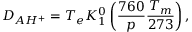Convert formula to latex. <formula><loc_0><loc_0><loc_500><loc_500>D _ { A H ^ { + } } = T _ { e } K _ { 1 } ^ { 0 } \left ( \frac { 7 6 0 } { p } \frac { T _ { m } } { 2 7 3 } \right ) ,</formula> 